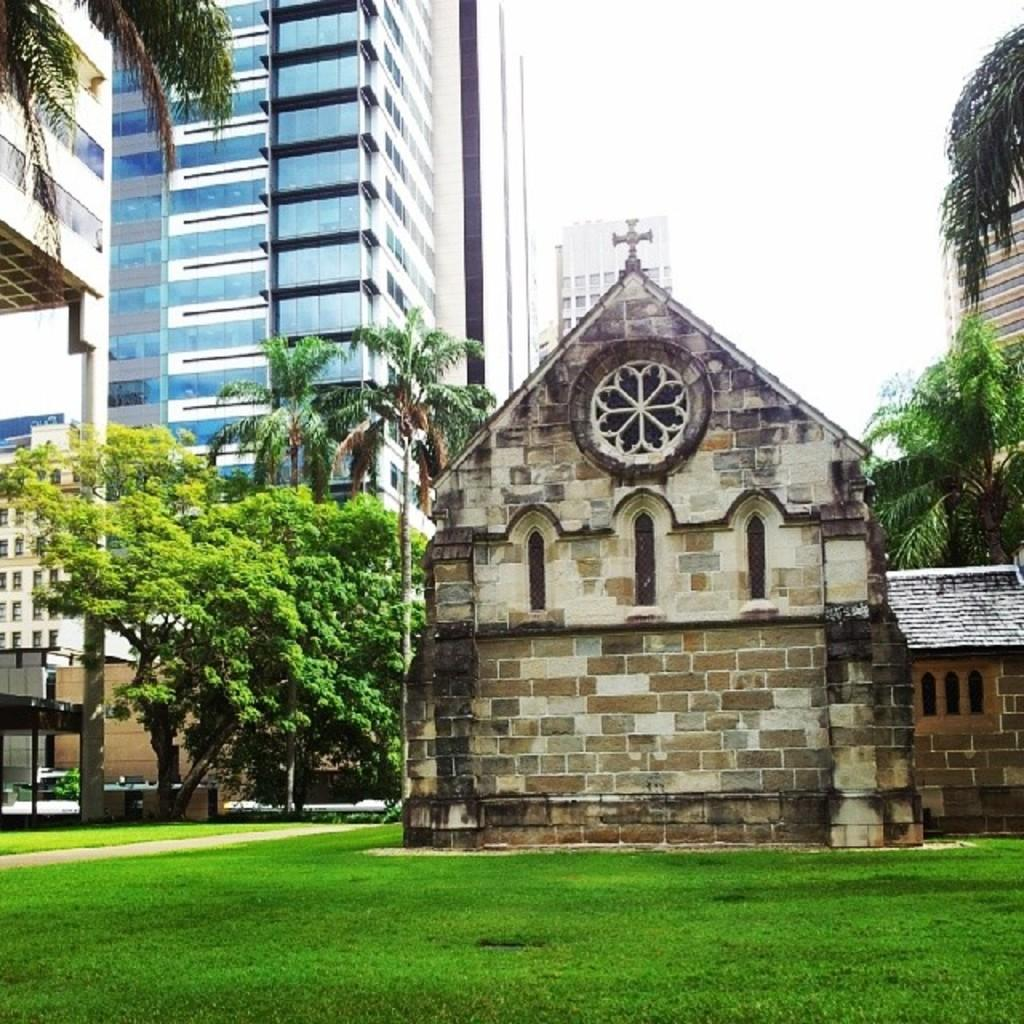What type of building is the main subject of the image? There is a church in the image. What is located in front of the church? There is a garden in front of the church. What other structures can be seen near the garden? There are tall buildings beside the garden. What type of vegetation is present in the image? There are trees in the image. How many apples are hanging from the trees in the image? There is no mention of apples in the image, so we cannot determine the number of apples present. 